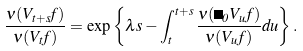Convert formula to latex. <formula><loc_0><loc_0><loc_500><loc_500>\frac { \nu ( V _ { t + s } f ) } { \nu ( V _ { t } f ) } = \exp \left \{ \lambda s - \int _ { t } ^ { t + s } \frac { \nu ( \Psi _ { 0 } V _ { u } f ) } { \nu ( V _ { u } f ) } d u \right \} .</formula> 